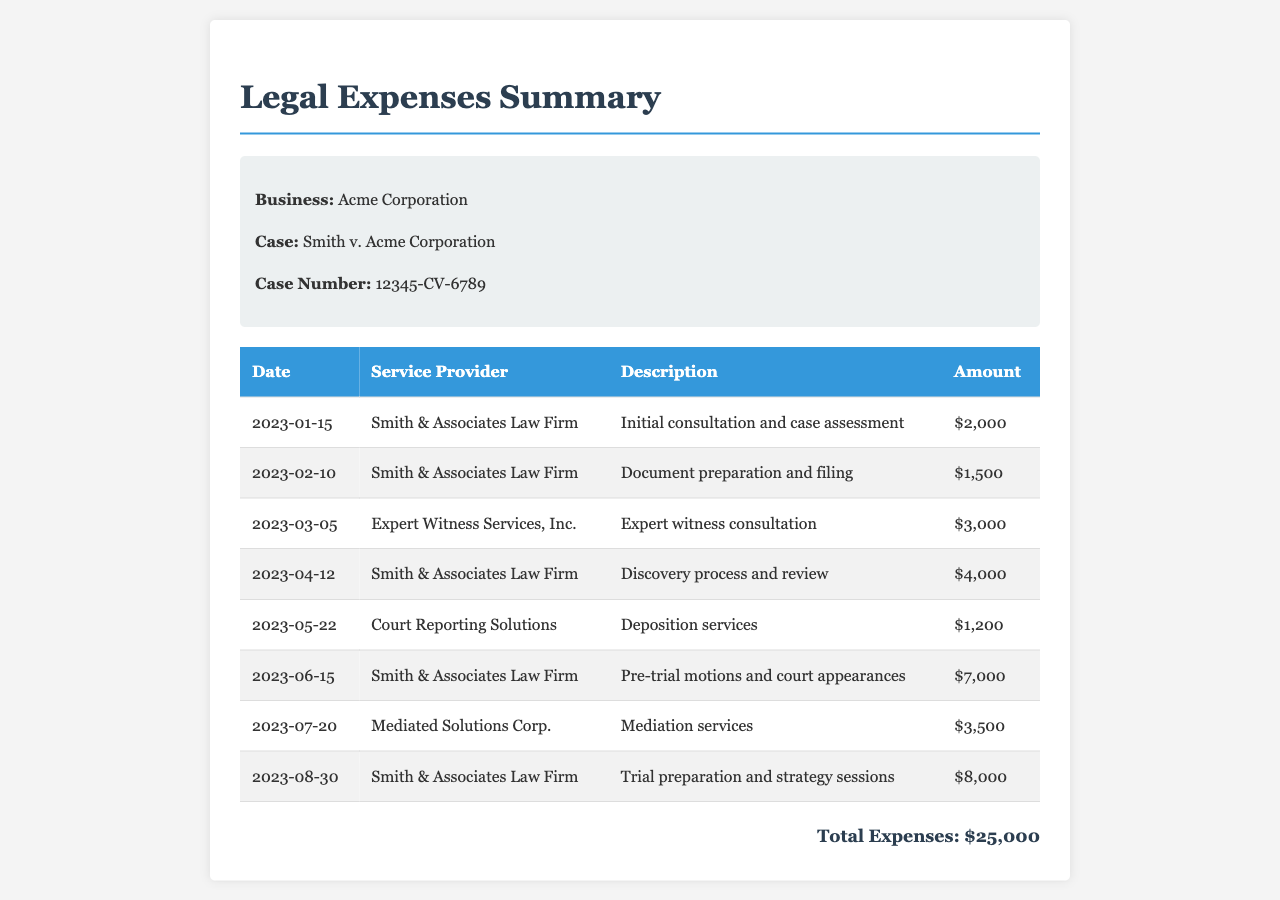What is the business name? The document specifies that the business is Acme Corporation.
Answer: Acme Corporation What is the case number? The case number is listed in the document as 12345-CV-6789.
Answer: 12345-CV-6789 Who is the service provider for the first entry? The first entry lists Smith & Associates Law Firm as the service provider.
Answer: Smith & Associates Law Firm What was the total amount billed by Smith & Associates Law Firm? The total amount billed is the sum of all entries for Smith & Associates Law Firm: $2,000 + $1,500 + $4,000 + $7,000 + $8,000 = $22,500.
Answer: $22,500 What services were provided on June 15, 2023? The services provided on June 15, 2023, included pre-trial motions and court appearances.
Answer: Pre-trial motions and court appearances Which service provider charged the most? The service provider that charged the most was Smith & Associates Law Firm for trial preparation and strategy sessions, amounting to $8,000.
Answer: Smith & Associates Law Firm On what date was the mediation service provided? Mediation services were provided on July 20, 2023.
Answer: July 20, 2023 What is the total amount of legal expenses incurred? The document states that the total expenses incurred amount to $25,000.
Answer: $25,000 How many entries were made in the document? The total number of entries can be counted in the table, which shows 8 service entries.
Answer: 8 